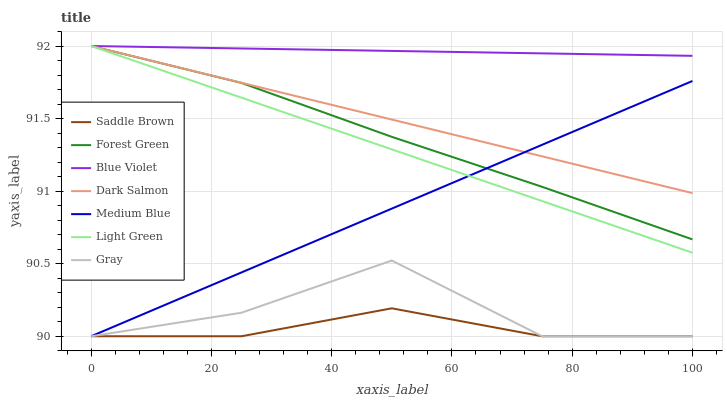Does Saddle Brown have the minimum area under the curve?
Answer yes or no. Yes. Does Blue Violet have the maximum area under the curve?
Answer yes or no. Yes. Does Medium Blue have the minimum area under the curve?
Answer yes or no. No. Does Medium Blue have the maximum area under the curve?
Answer yes or no. No. Is Light Green the smoothest?
Answer yes or no. Yes. Is Gray the roughest?
Answer yes or no. Yes. Is Medium Blue the smoothest?
Answer yes or no. No. Is Medium Blue the roughest?
Answer yes or no. No. Does Gray have the lowest value?
Answer yes or no. Yes. Does Dark Salmon have the lowest value?
Answer yes or no. No. Does Blue Violet have the highest value?
Answer yes or no. Yes. Does Medium Blue have the highest value?
Answer yes or no. No. Is Saddle Brown less than Dark Salmon?
Answer yes or no. Yes. Is Blue Violet greater than Medium Blue?
Answer yes or no. Yes. Does Dark Salmon intersect Medium Blue?
Answer yes or no. Yes. Is Dark Salmon less than Medium Blue?
Answer yes or no. No. Is Dark Salmon greater than Medium Blue?
Answer yes or no. No. Does Saddle Brown intersect Dark Salmon?
Answer yes or no. No. 